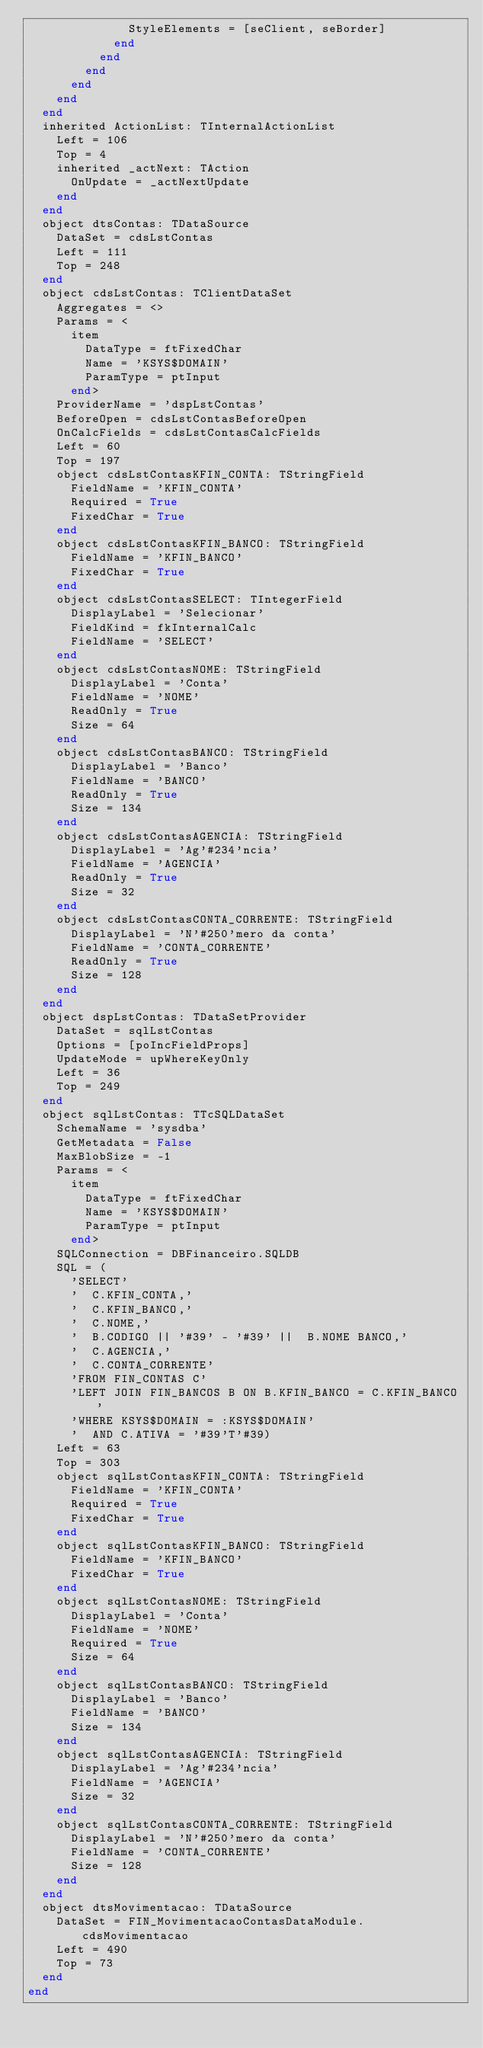<code> <loc_0><loc_0><loc_500><loc_500><_Pascal_>              StyleElements = [seClient, seBorder]
            end
          end
        end
      end
    end
  end
  inherited ActionList: TInternalActionList
    Left = 106
    Top = 4
    inherited _actNext: TAction
      OnUpdate = _actNextUpdate
    end
  end
  object dtsContas: TDataSource
    DataSet = cdsLstContas
    Left = 111
    Top = 248
  end
  object cdsLstContas: TClientDataSet
    Aggregates = <>
    Params = <
      item
        DataType = ftFixedChar
        Name = 'KSYS$DOMAIN'
        ParamType = ptInput
      end>
    ProviderName = 'dspLstContas'
    BeforeOpen = cdsLstContasBeforeOpen
    OnCalcFields = cdsLstContasCalcFields
    Left = 60
    Top = 197
    object cdsLstContasKFIN_CONTA: TStringField
      FieldName = 'KFIN_CONTA'
      Required = True
      FixedChar = True
    end
    object cdsLstContasKFIN_BANCO: TStringField
      FieldName = 'KFIN_BANCO'
      FixedChar = True
    end
    object cdsLstContasSELECT: TIntegerField
      DisplayLabel = 'Selecionar'
      FieldKind = fkInternalCalc
      FieldName = 'SELECT'
    end
    object cdsLstContasNOME: TStringField
      DisplayLabel = 'Conta'
      FieldName = 'NOME'
      ReadOnly = True
      Size = 64
    end
    object cdsLstContasBANCO: TStringField
      DisplayLabel = 'Banco'
      FieldName = 'BANCO'
      ReadOnly = True
      Size = 134
    end
    object cdsLstContasAGENCIA: TStringField
      DisplayLabel = 'Ag'#234'ncia'
      FieldName = 'AGENCIA'
      ReadOnly = True
      Size = 32
    end
    object cdsLstContasCONTA_CORRENTE: TStringField
      DisplayLabel = 'N'#250'mero da conta'
      FieldName = 'CONTA_CORRENTE'
      ReadOnly = True
      Size = 128
    end
  end
  object dspLstContas: TDataSetProvider
    DataSet = sqlLstContas
    Options = [poIncFieldProps]
    UpdateMode = upWhereKeyOnly
    Left = 36
    Top = 249
  end
  object sqlLstContas: TTcSQLDataSet
    SchemaName = 'sysdba'
    GetMetadata = False
    MaxBlobSize = -1
    Params = <
      item
        DataType = ftFixedChar
        Name = 'KSYS$DOMAIN'
        ParamType = ptInput
      end>
    SQLConnection = DBFinanceiro.SQLDB
    SQL = (
      'SELECT'
      '  C.KFIN_CONTA,'
      '  C.KFIN_BANCO,'
      '  C.NOME,'
      '  B.CODIGO || '#39' - '#39' ||  B.NOME BANCO,'
      '  C.AGENCIA,'
      '  C.CONTA_CORRENTE'
      'FROM FIN_CONTAS C'
      'LEFT JOIN FIN_BANCOS B ON B.KFIN_BANCO = C.KFIN_BANCO'
      'WHERE KSYS$DOMAIN = :KSYS$DOMAIN'
      '  AND C.ATIVA = '#39'T'#39)
    Left = 63
    Top = 303
    object sqlLstContasKFIN_CONTA: TStringField
      FieldName = 'KFIN_CONTA'
      Required = True
      FixedChar = True
    end
    object sqlLstContasKFIN_BANCO: TStringField
      FieldName = 'KFIN_BANCO'
      FixedChar = True
    end
    object sqlLstContasNOME: TStringField
      DisplayLabel = 'Conta'
      FieldName = 'NOME'
      Required = True
      Size = 64
    end
    object sqlLstContasBANCO: TStringField
      DisplayLabel = 'Banco'
      FieldName = 'BANCO'
      Size = 134
    end
    object sqlLstContasAGENCIA: TStringField
      DisplayLabel = 'Ag'#234'ncia'
      FieldName = 'AGENCIA'
      Size = 32
    end
    object sqlLstContasCONTA_CORRENTE: TStringField
      DisplayLabel = 'N'#250'mero da conta'
      FieldName = 'CONTA_CORRENTE'
      Size = 128
    end
  end
  object dtsMovimentacao: TDataSource
    DataSet = FIN_MovimentacaoContasDataModule.cdsMovimentacao
    Left = 490
    Top = 73
  end
end
</code> 